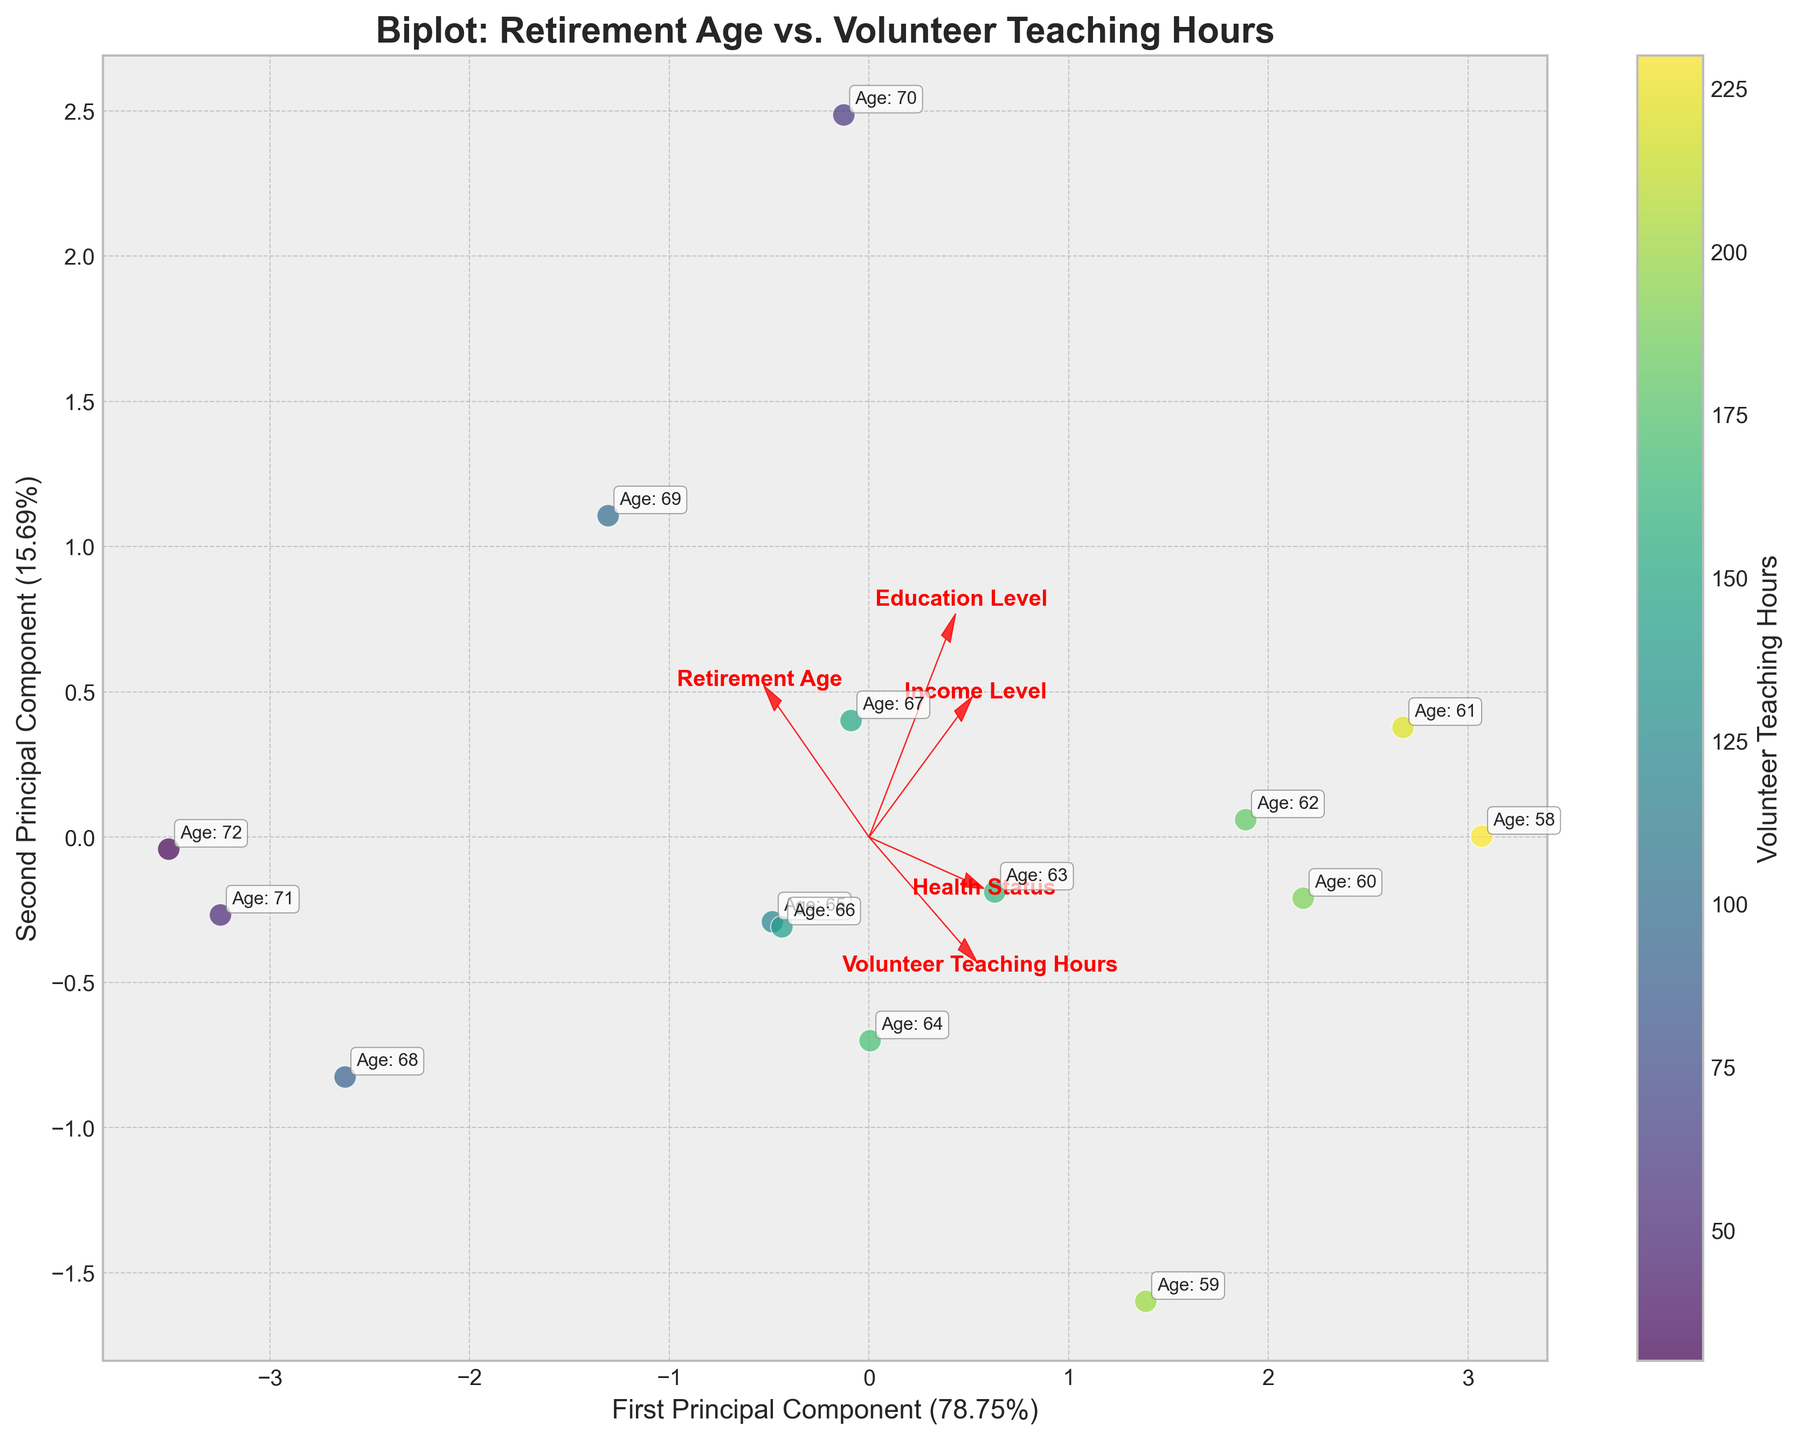What is the title of the plot? The title of the plot is typically found at the top center of the figure, which describes what the plot represents. In this case, the title reads "Biplot: Retirement Age vs. Volunteer Teaching Hours".
Answer: Biplot: Retirement Age vs. Volunteer Teaching Hours How many principal components are displayed on the plot? The number of principal components (PCs) is indicated by the presence of two axes labeled with variance percentages, representing the first and second principal components. Here, two principal components are shown.
Answer: Two What is the color indicating in the scatter points? The color bar on the right side of the plot indicates that the color of the scatter points represents the "Volunteer Teaching Hours".
Answer: Volunteer Teaching Hours Which direction does the arrow for "Retirement Age" point? The arrows represent the features and their directions. The arrow for "Retirement Age" points predominantly to the right and slightly upward.
Answer: Right and slightly upward Which feature has the strongest association with the first principal component? The length and direction of the arrows toward the first principal component's axis indicate the strength of association. The longest arrow closely aligned with the first principal component axis is "Retirement Age".
Answer: Retirement Age How many data points represent individuals who retired before age 60? The biplot annotations near the scatter points show age values. By counting, there are four points annotated with ages below 60: 59, 58, 61, and 60.
Answer: Four Do individuals with a Ph.D. tend to have a higher or lower number of volunteer teaching hours? By observing the scatter points' colors and their annotations, points with "Age" annotations for Ph.D. holders are near the higher end of the color spectrum (darker colors), suggesting higher volunteer teaching hours.
Answer: Higher Which has more influence on the second principal component: Health Status or Education Level? Comparing the lengths and directions of the arrows projected onto the second principal component's axis, "Health Status" shows a stronger projection than "Education Level".
Answer: Health Status Is there a noticeable trend between retirement age and volunteer hours based on the plot? By visually examining the scatter points' distribution and their color gradient, a trend can be inferred where some lower retirement ages have higher volunteer hours, but it isn't strictly linear.
Answer: Yes, but not strictly linear What percentage of variance does the second principal component explain? The label of the second principal component on the y-axis provides this information, which can be read directly from there.
Answer: Approximately 27% 